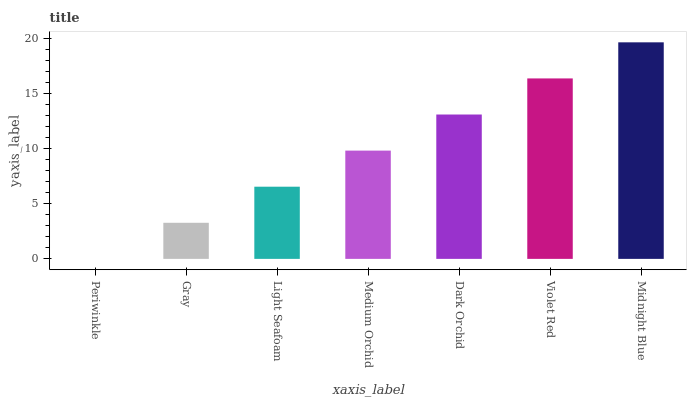Is Periwinkle the minimum?
Answer yes or no. Yes. Is Midnight Blue the maximum?
Answer yes or no. Yes. Is Gray the minimum?
Answer yes or no. No. Is Gray the maximum?
Answer yes or no. No. Is Gray greater than Periwinkle?
Answer yes or no. Yes. Is Periwinkle less than Gray?
Answer yes or no. Yes. Is Periwinkle greater than Gray?
Answer yes or no. No. Is Gray less than Periwinkle?
Answer yes or no. No. Is Medium Orchid the high median?
Answer yes or no. Yes. Is Medium Orchid the low median?
Answer yes or no. Yes. Is Light Seafoam the high median?
Answer yes or no. No. Is Violet Red the low median?
Answer yes or no. No. 